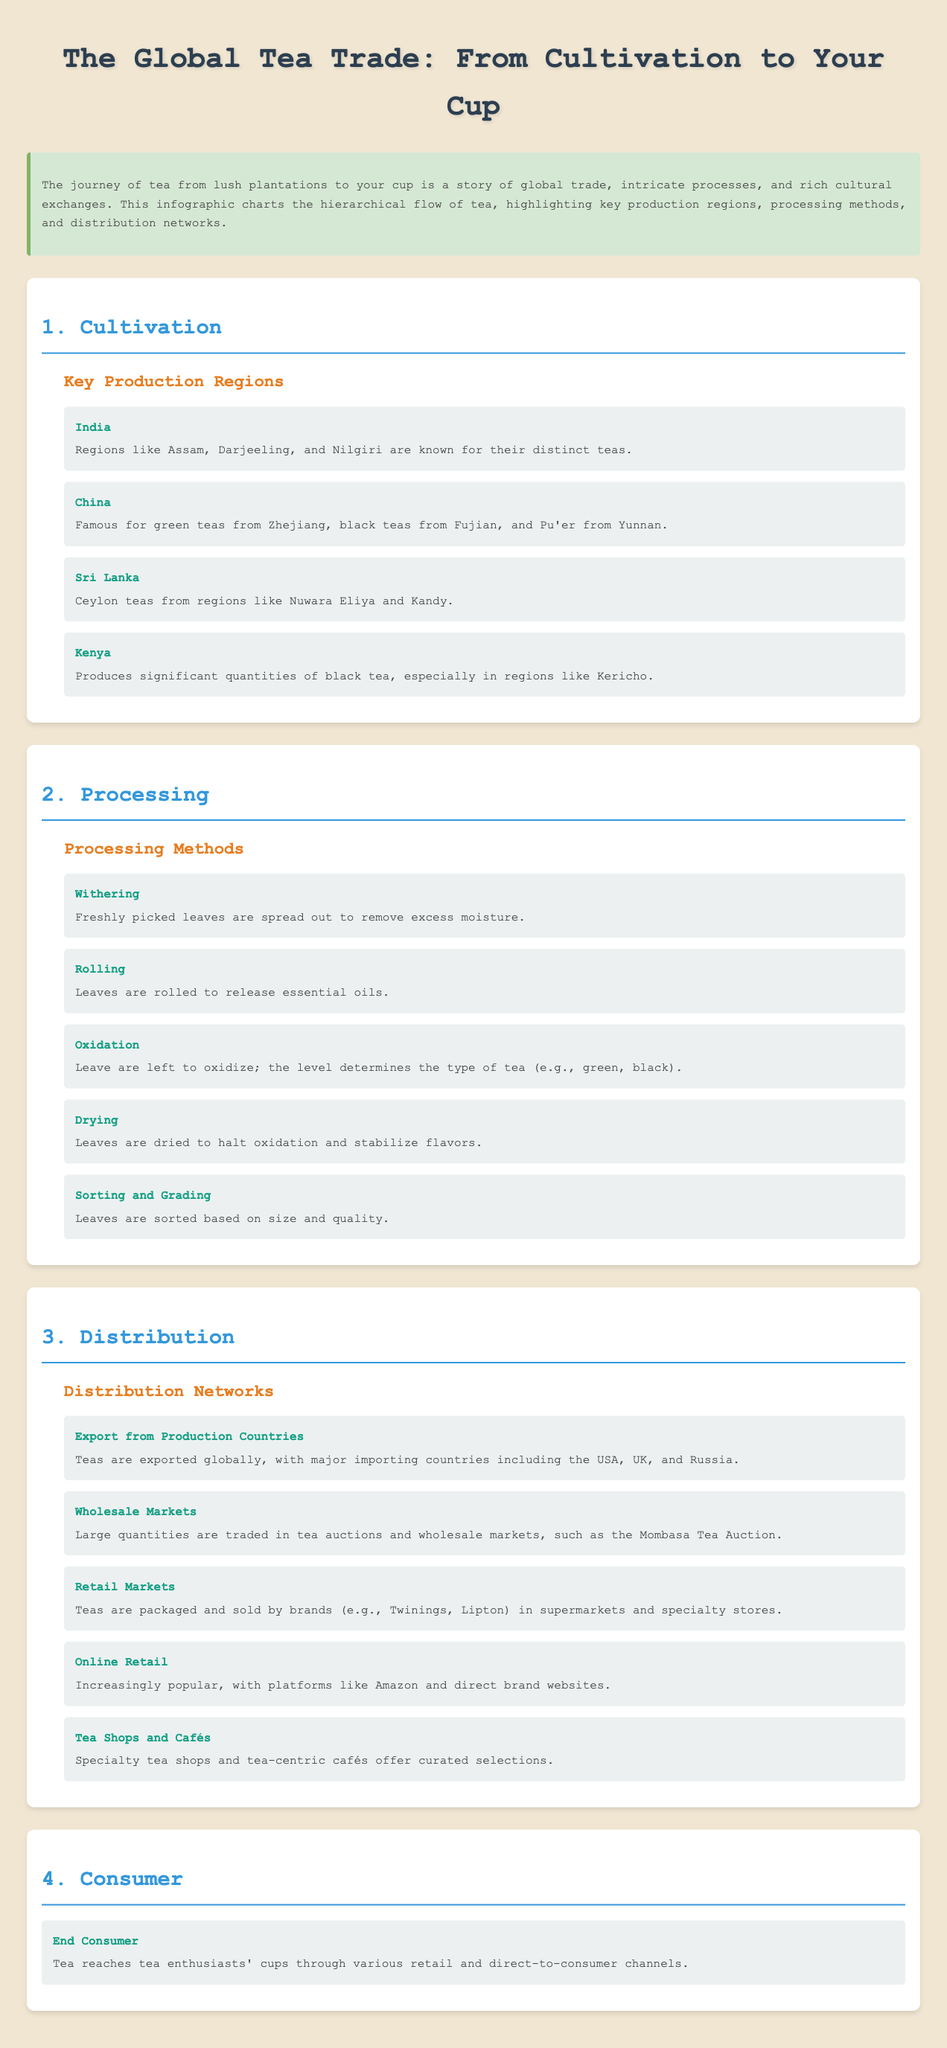What are key production regions for tea? The document lists India, China, Sri Lanka, and Kenya as key production regions for tea cultivation.
Answer: India, China, Sri Lanka, Kenya What type of tea is known from Sri Lanka? The document mentions "Ceylon teas" specifically from regions like Nuwara Eliya and Kandy in Sri Lanka.
Answer: Ceylon teas Which processing step follows withering? The document states that rolling is the processing step that follows withering in tea production.
Answer: Rolling How many main processing methods are listed? The document enumerates five main processing methods for tea, such as withering, rolling, oxidation, drying, and sorting and grading.
Answer: Five Which country is a significant importer of tea? The document highlights the USA as one of the major importing countries for exported tea.
Answer: USA What is a common retail channel for selling tea? The document indicates that tea is packaged and sold by brands in supermarkets as a common retail channel.
Answer: Supermarkets What is the final step in the tea supply chain? The document indicates that tea reaches tea enthusiasts' cups as the final step in the supply chain.
Answer: End Consumer What is an example of an online retail platform for tea? The document mentions Amazon as an increasingly popular online retail platform for purchasing tea.
Answer: Amazon In which level is "Oxidation" categorized? Oxidation is categorized under the "Processing" level in the document hierarchy.
Answer: Processing 